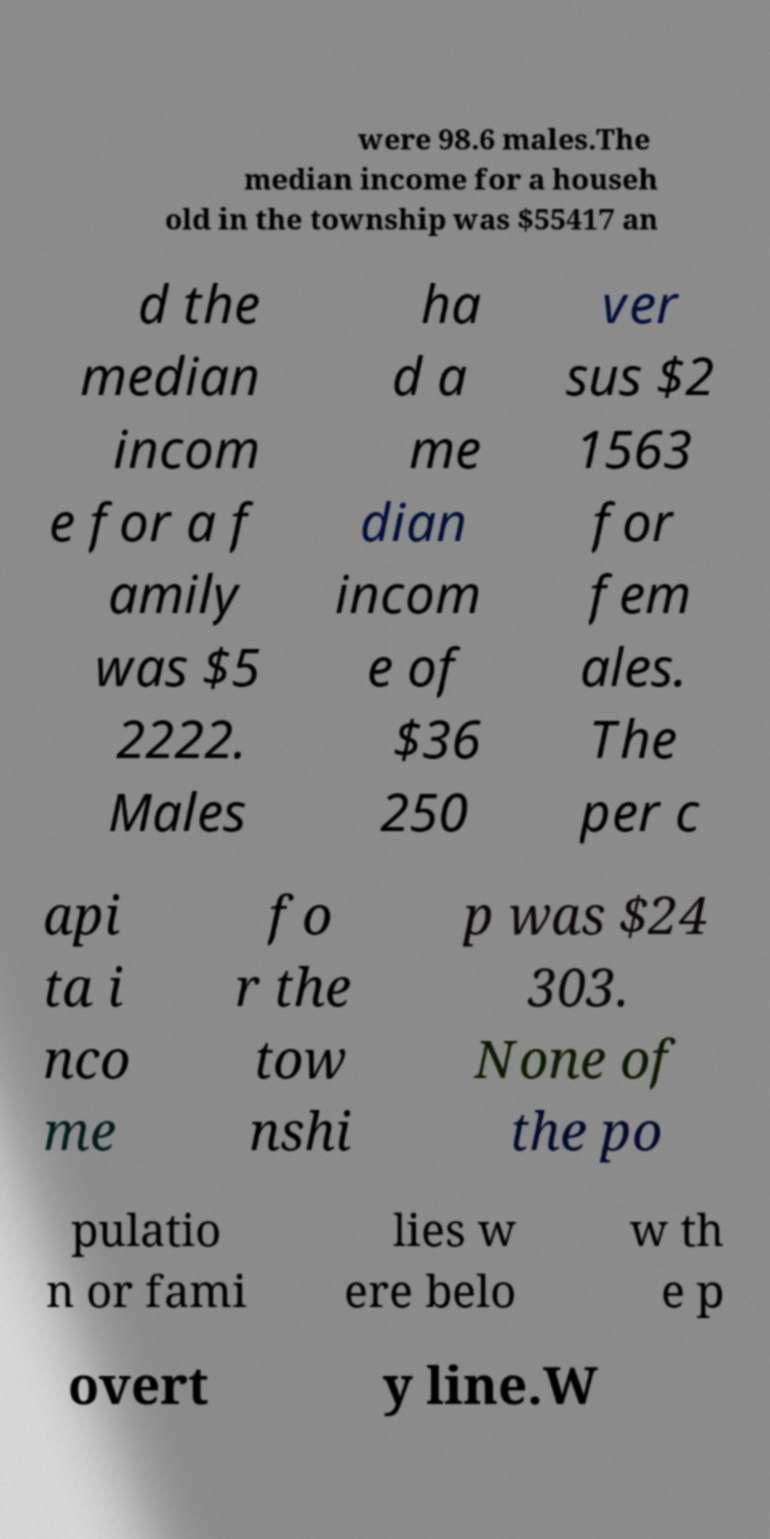Please identify and transcribe the text found in this image. were 98.6 males.The median income for a househ old in the township was $55417 an d the median incom e for a f amily was $5 2222. Males ha d a me dian incom e of $36 250 ver sus $2 1563 for fem ales. The per c api ta i nco me fo r the tow nshi p was $24 303. None of the po pulatio n or fami lies w ere belo w th e p overt y line.W 